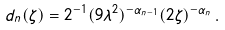Convert formula to latex. <formula><loc_0><loc_0><loc_500><loc_500>d _ { n } ( \zeta ) = 2 ^ { - 1 } ( 9 \lambda ^ { 2 } ) ^ { - \alpha _ { n - 1 } } ( 2 \zeta ) ^ { - \alpha _ { n } } \, .</formula> 